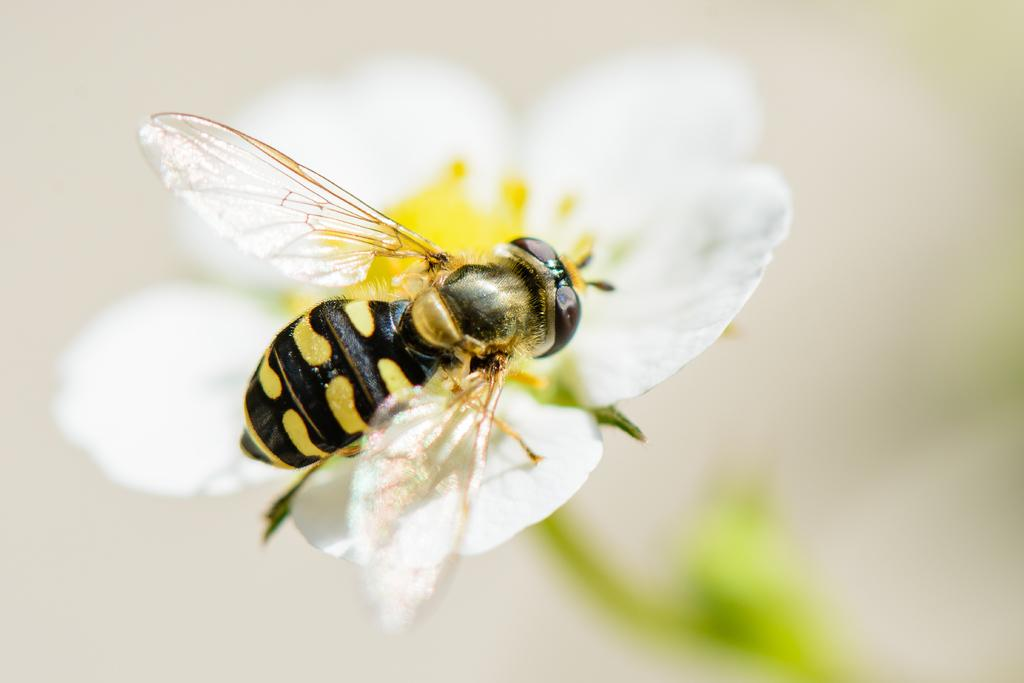What is present in the image? There is a fly in the image. Where is the fly located? The fly is on a flower. What religious symbol can be seen on the fly in the image? There is no religious symbol present on the fly in the image. 